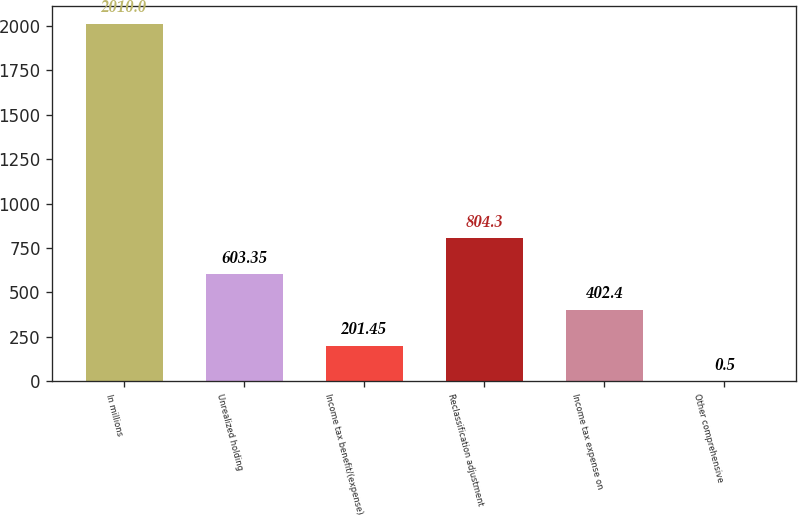Convert chart. <chart><loc_0><loc_0><loc_500><loc_500><bar_chart><fcel>In millions<fcel>Unrealized holding<fcel>Income tax benefit/(expense)<fcel>Reclassification adjustment<fcel>Income tax expense on<fcel>Other comprehensive<nl><fcel>2010<fcel>603.35<fcel>201.45<fcel>804.3<fcel>402.4<fcel>0.5<nl></chart> 